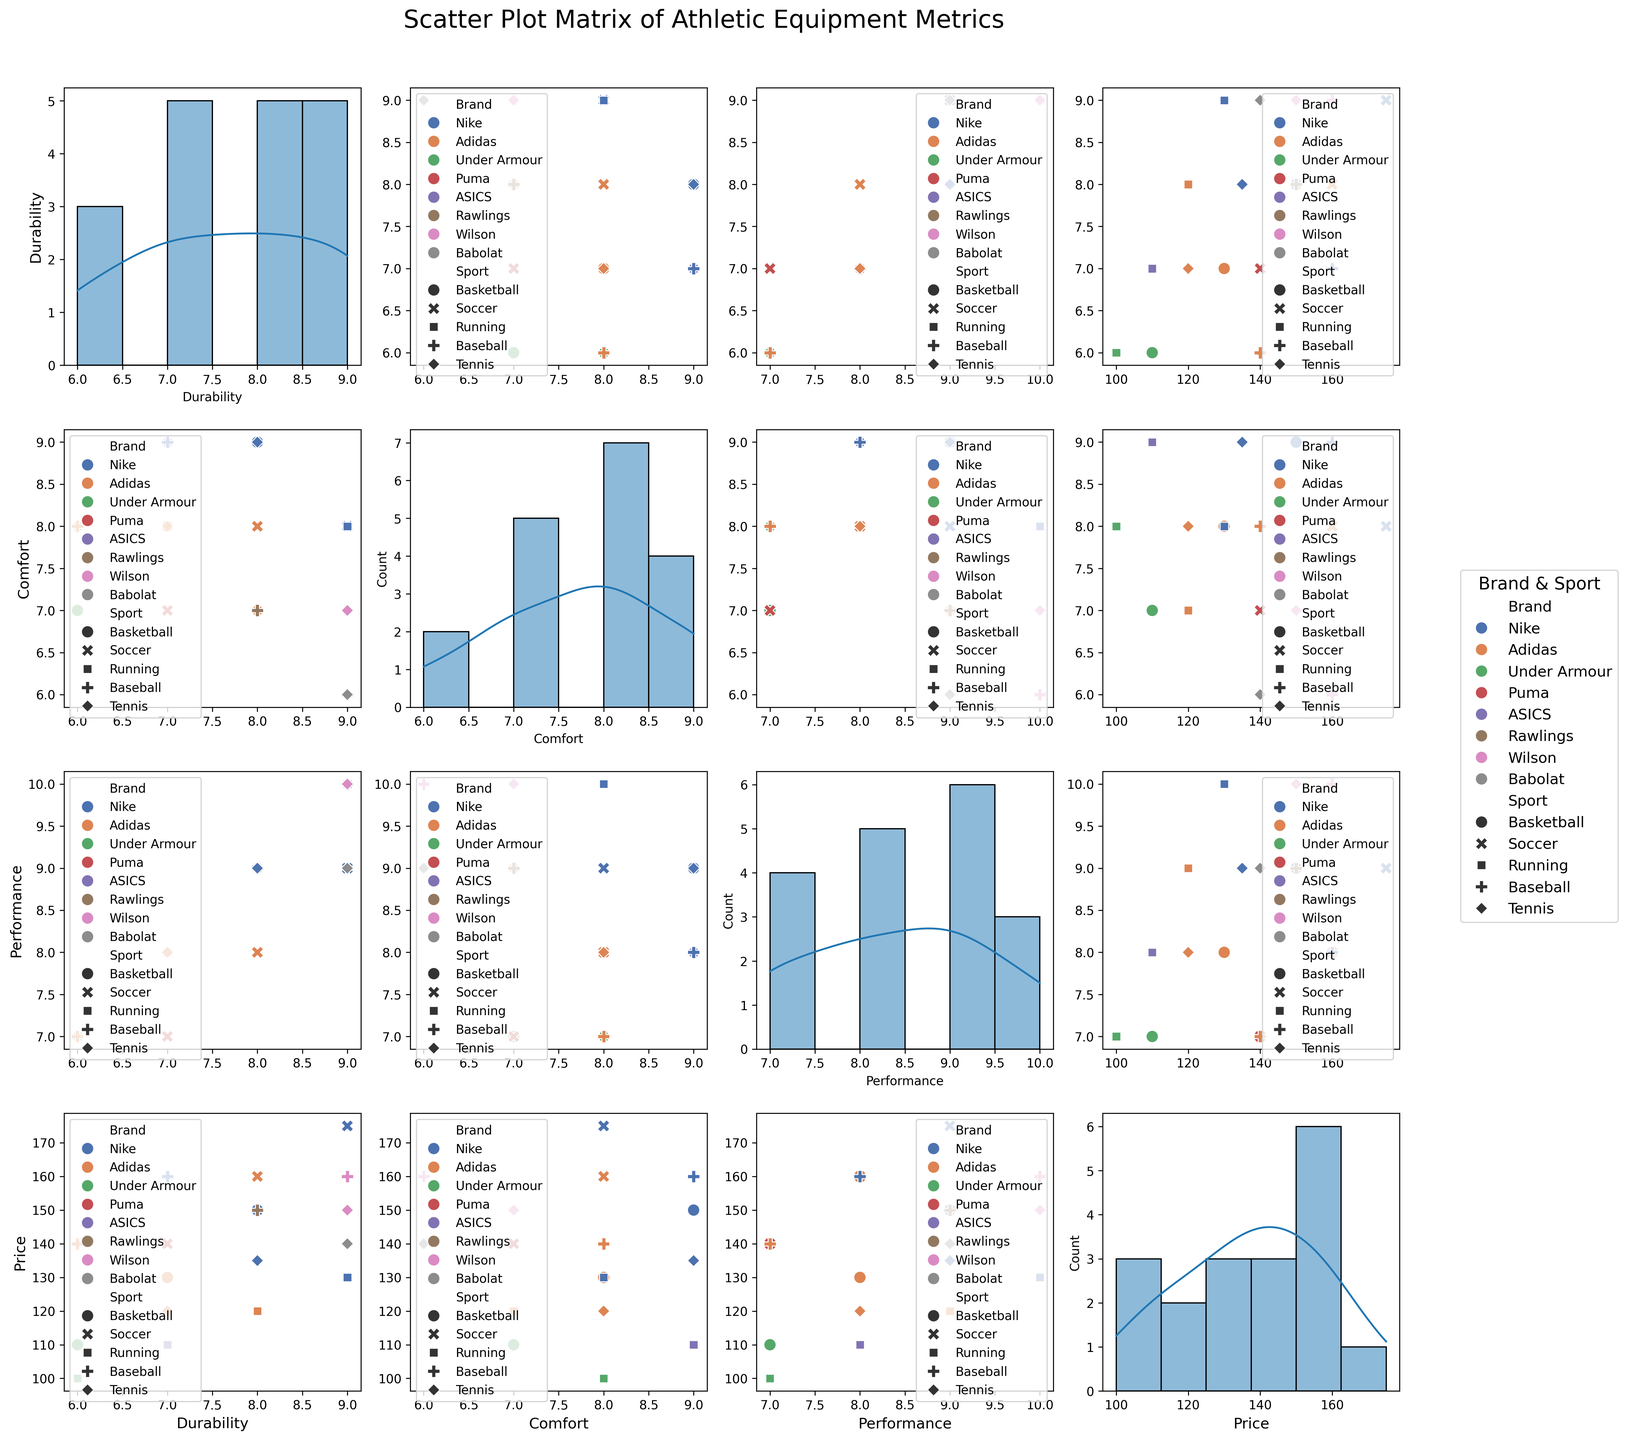What is the title of the figure? The title can be found at the top center of the figure, written in a larger font than other text elements.
Answer: Scatter Plot Matrix of Athletic Equipment Metrics Which brand has the highest number of data points represented in the figure? By observing the colors corresponding to each brand, Nike appears the most frequently across the scatter plots and histograms.
Answer: Nike How does the durability of Nike’s basketball equipment compare to Adidas' basketball equipment? Locate the "Durability vs. Brand" scatter plot and check the points for Nike (Basketball) and Adidas (Basketball). Nike has a durability of 8, while Adidas has a durability of 7.
Answer: Nike's basketball equipment has higher durability What relationship can be observed between Comfort and Price for soccer equipment? Look at the scatter plot of Comfort versus Price, focusing on points marked as Soccer. Generally, a higher comfort score is associated with a higher price.
Answer: Higher comfort is generally associated with a higher price What is the range of performance values for running equipment from all brands? Look at the "Performance vs. Comfort" scatter plot and observe points marked as Running. The performance values range from 7 to 10.
Answer: 7 to 10 Which sport shows the widest variation in durability values across brands? Compare the spread of points in "Durability vs. Sports" scatter plots. Soccer shows points ranging from 6 to 9, whereas other sports have smaller ranges.
Answer: Soccer Are there any brands that have both high comfort and high performance for tennis equipment? Refer to the "Comfort vs. Performance" scatter plot and look for points representing Tennis with high values in both axes. Both Nike and Wilson have high values in comfort (9 and 7 respectively) and performance (9 and 10 respectively).
Answer: Nike, Wilson For running equipment, how does the performance vary with price? Observe the relationship in the scatter plot of Performance vs. Price for points marked as Running. Generally, as the price increases, performance also tends to increase.
Answer: Performance tends to increase with price Which brand has the highest comfort for baseball equipment? Look at the scatter plot of Comfort vs. Brand, focusing on the points marked as Baseball. Nike and Wilson have the highest comfort value of 9.
Answer: Nike, Wilson What is the most frequently occurring comfort value across all sports? Check the histograms on the diagonal for the Comfort parameter. The value 8 appears most frequently.
Answer: 8 